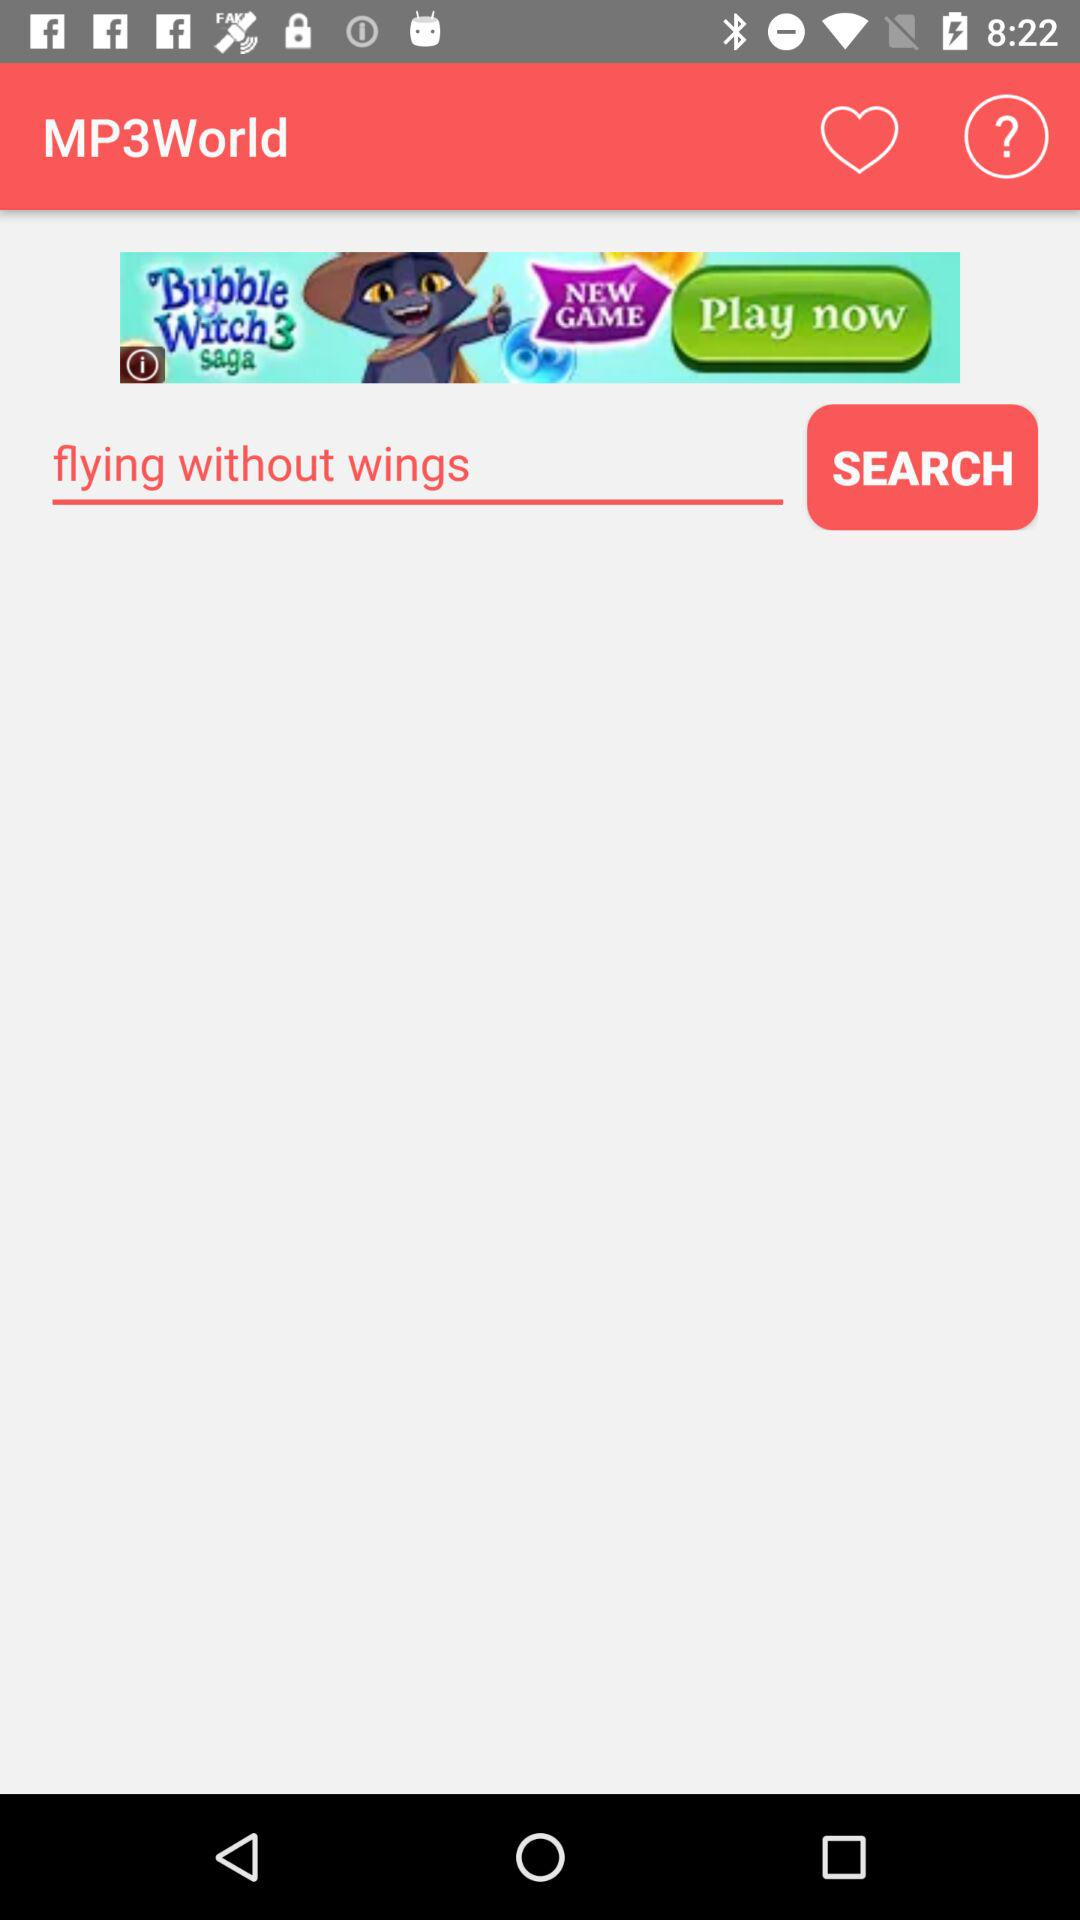What song is searched? The searched song is "flying without wings". 